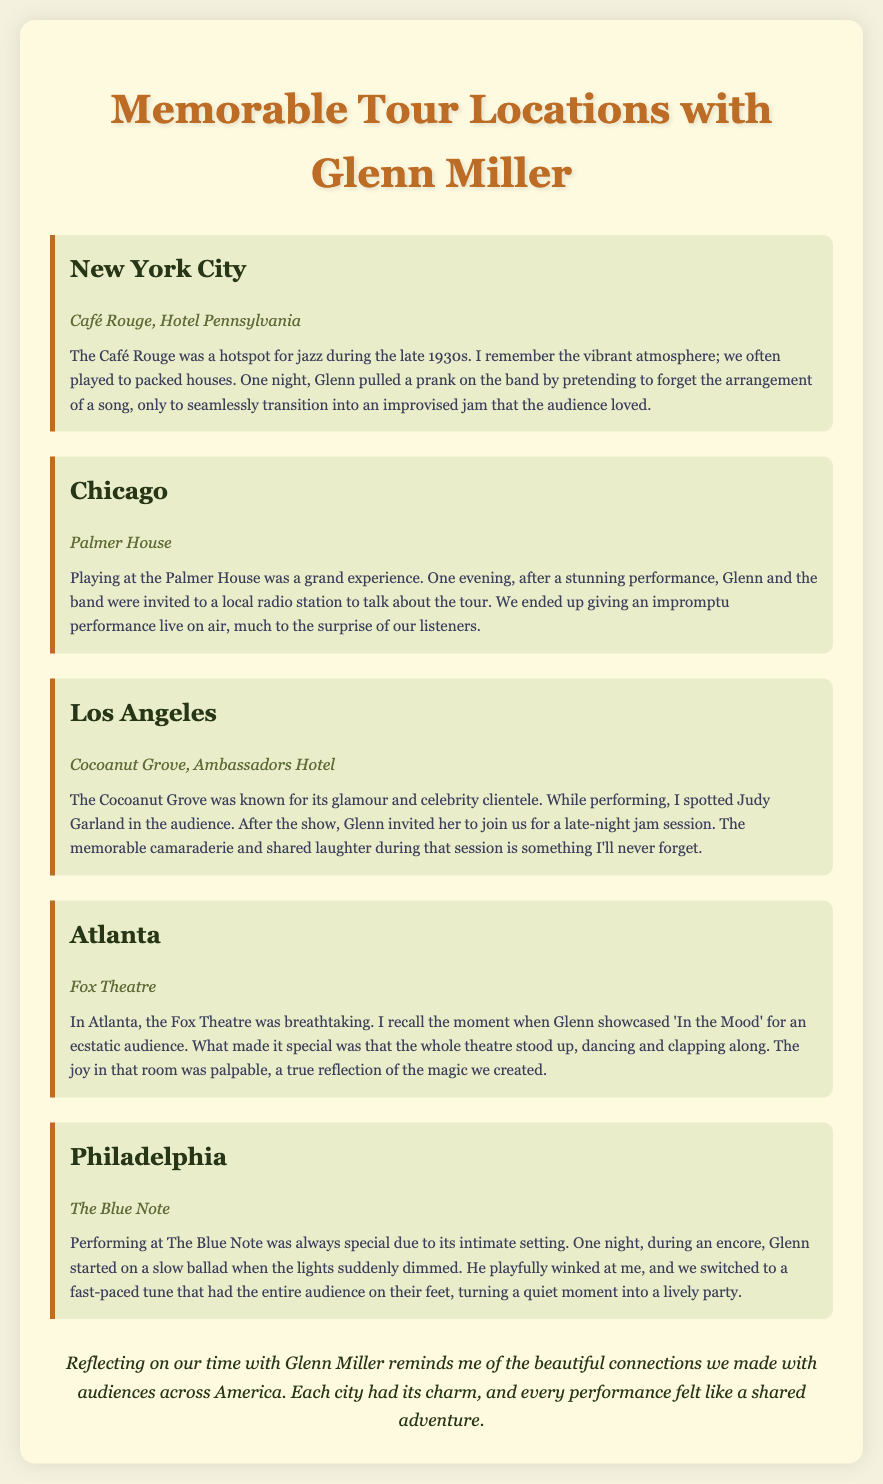What city hosted the Café Rouge? The document mentions New York City as the location of Café Rouge.
Answer: New York City Which venue in Chicago is highlighted? The highlighted venue in Chicago is the Palmer House, as noted in the document.
Answer: Palmer House What song did Glenn showcase in Atlanta? The document states that Glenn showcased 'In the Mood' during a performance in Atlanta.
Answer: In the Mood Who did Glenn invite to join the jam session in Los Angeles? The document indicates that Glenn invited Judy Garland to the jam session after the show in Los Angeles.
Answer: Judy Garland What was the audience's reaction during 'In the Mood' at the Fox Theatre? According to the document, the audience stood up, dancing and clapping along, showing their ecstatic reaction.
Answer: Stood up, dancing and clapping How did Glenn and the band end an encore at The Blue Note? The document describes that Glenn playfully switched from a slow ballad to a fast-paced tune during the encore at The Blue Note.
Answer: Fast-paced tune 